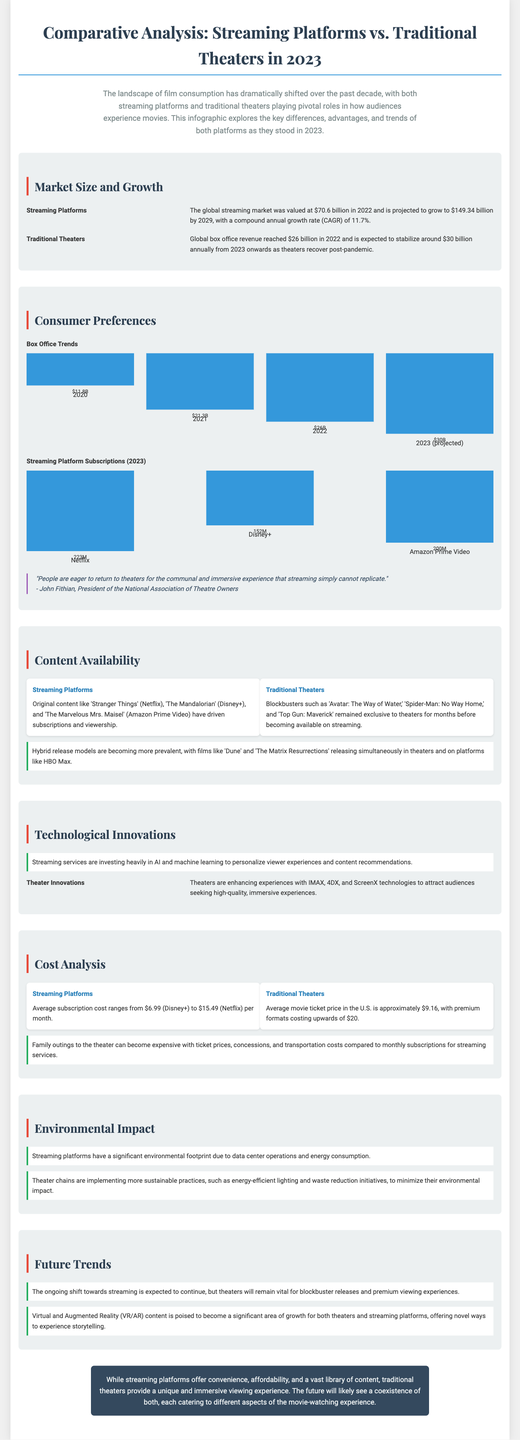what is the projected global streaming market value by 2029? The projected global streaming market value by 2029 is stated in the document, which is $149.34 billion.
Answer: $149.34 billion what was the global box office revenue in 2022? The document specifies that global box office revenue reached $26 billion in 2022.
Answer: $26 billion how many Netflix subscriptions were there in 2023? The document provides the number of Netflix subscriptions in 2023 as 223 million.
Answer: 223M which streaming platform has the highest subscription count in 2023? The highest subscription count among the streaming platforms in 2023 is mentioned for Netflix.
Answer: Netflix why are theaters expected to remain vital according to the predictions? The document implies that theaters are vital for blockbuster releases and premium viewing experiences, indicating their unique role.
Answer: blockbuster releases what was the average movie ticket price in the U.S.? The average movie ticket price in the U.S. is reported in the document as approximately $9.16.
Answer: $9.16 what technological innovations are theaters implementing? The document mentions that theaters are enhancing experiences with IMAX, 4DX, and ScreenX technologies.
Answer: IMAX, 4DX, and ScreenX which original content drove subscriptions for streaming platforms? The document lists original content such as 'Stranger Things', 'The Mandalorian', and 'The Marvelous Mrs. Maisel' as drivers for subscriptions.
Answer: 'Stranger Things', 'The Mandalorian', and 'The Marvelous Mrs. Maisel' how is the environmental impact of streaming platforms characterized? The document indicates that streaming platforms have a significant environmental footprint due to data center operations and energy consumption.
Answer: significant environmental footprint 